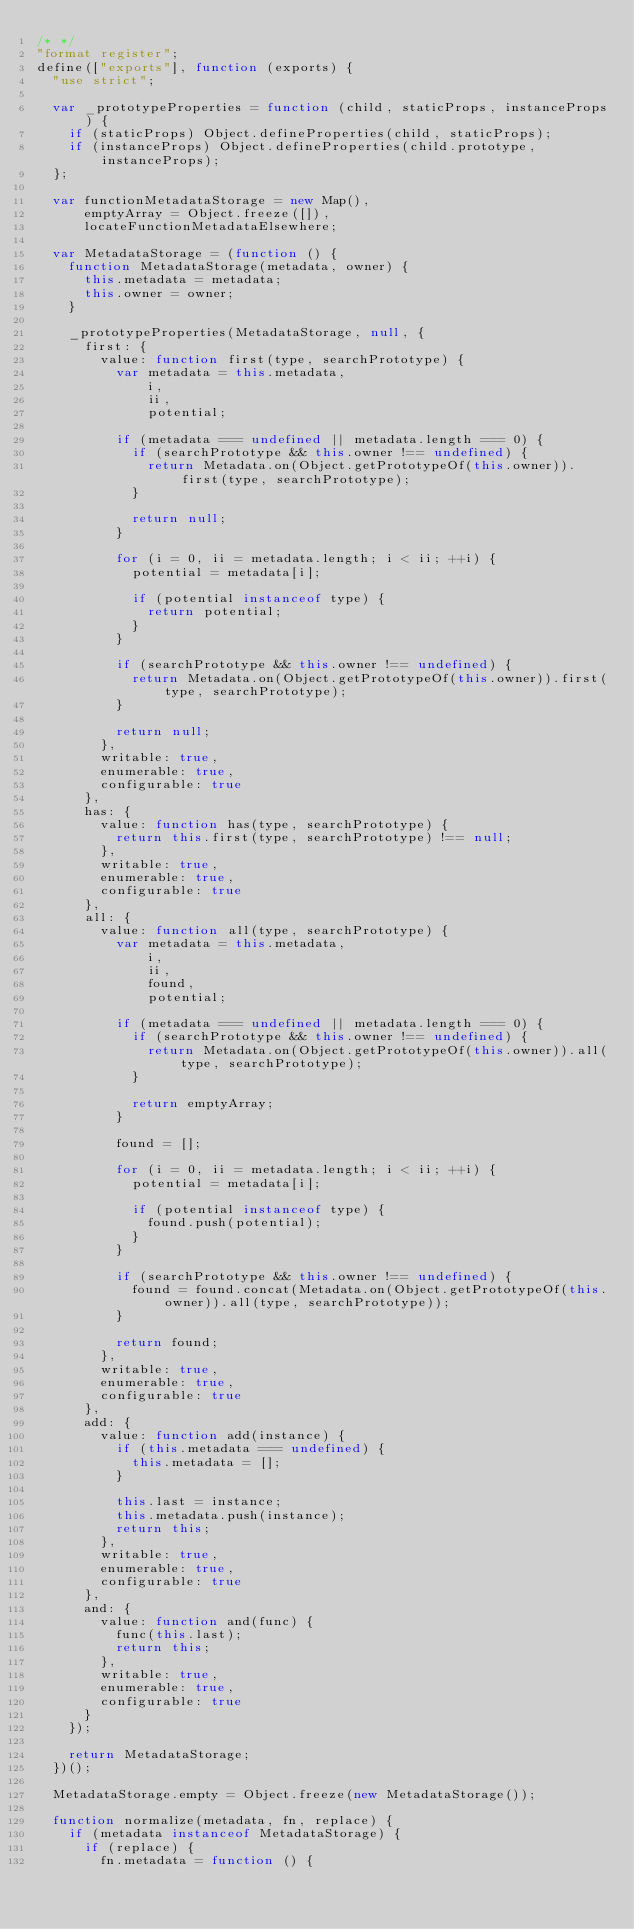<code> <loc_0><loc_0><loc_500><loc_500><_JavaScript_>/* */ 
"format register";
define(["exports"], function (exports) {
  "use strict";

  var _prototypeProperties = function (child, staticProps, instanceProps) {
    if (staticProps) Object.defineProperties(child, staticProps);
    if (instanceProps) Object.defineProperties(child.prototype, instanceProps);
  };

  var functionMetadataStorage = new Map(),
      emptyArray = Object.freeze([]),
      locateFunctionMetadataElsewhere;

  var MetadataStorage = (function () {
    function MetadataStorage(metadata, owner) {
      this.metadata = metadata;
      this.owner = owner;
    }

    _prototypeProperties(MetadataStorage, null, {
      first: {
        value: function first(type, searchPrototype) {
          var metadata = this.metadata,
              i,
              ii,
              potential;

          if (metadata === undefined || metadata.length === 0) {
            if (searchPrototype && this.owner !== undefined) {
              return Metadata.on(Object.getPrototypeOf(this.owner)).first(type, searchPrototype);
            }

            return null;
          }

          for (i = 0, ii = metadata.length; i < ii; ++i) {
            potential = metadata[i];

            if (potential instanceof type) {
              return potential;
            }
          }

          if (searchPrototype && this.owner !== undefined) {
            return Metadata.on(Object.getPrototypeOf(this.owner)).first(type, searchPrototype);
          }

          return null;
        },
        writable: true,
        enumerable: true,
        configurable: true
      },
      has: {
        value: function has(type, searchPrototype) {
          return this.first(type, searchPrototype) !== null;
        },
        writable: true,
        enumerable: true,
        configurable: true
      },
      all: {
        value: function all(type, searchPrototype) {
          var metadata = this.metadata,
              i,
              ii,
              found,
              potential;

          if (metadata === undefined || metadata.length === 0) {
            if (searchPrototype && this.owner !== undefined) {
              return Metadata.on(Object.getPrototypeOf(this.owner)).all(type, searchPrototype);
            }

            return emptyArray;
          }

          found = [];

          for (i = 0, ii = metadata.length; i < ii; ++i) {
            potential = metadata[i];

            if (potential instanceof type) {
              found.push(potential);
            }
          }

          if (searchPrototype && this.owner !== undefined) {
            found = found.concat(Metadata.on(Object.getPrototypeOf(this.owner)).all(type, searchPrototype));
          }

          return found;
        },
        writable: true,
        enumerable: true,
        configurable: true
      },
      add: {
        value: function add(instance) {
          if (this.metadata === undefined) {
            this.metadata = [];
          }

          this.last = instance;
          this.metadata.push(instance);
          return this;
        },
        writable: true,
        enumerable: true,
        configurable: true
      },
      and: {
        value: function and(func) {
          func(this.last);
          return this;
        },
        writable: true,
        enumerable: true,
        configurable: true
      }
    });

    return MetadataStorage;
  })();

  MetadataStorage.empty = Object.freeze(new MetadataStorage());

  function normalize(metadata, fn, replace) {
    if (metadata instanceof MetadataStorage) {
      if (replace) {
        fn.metadata = function () {</code> 